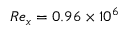<formula> <loc_0><loc_0><loc_500><loc_500>R e _ { x } = 0 . 9 6 \times 1 0 ^ { 6 }</formula> 